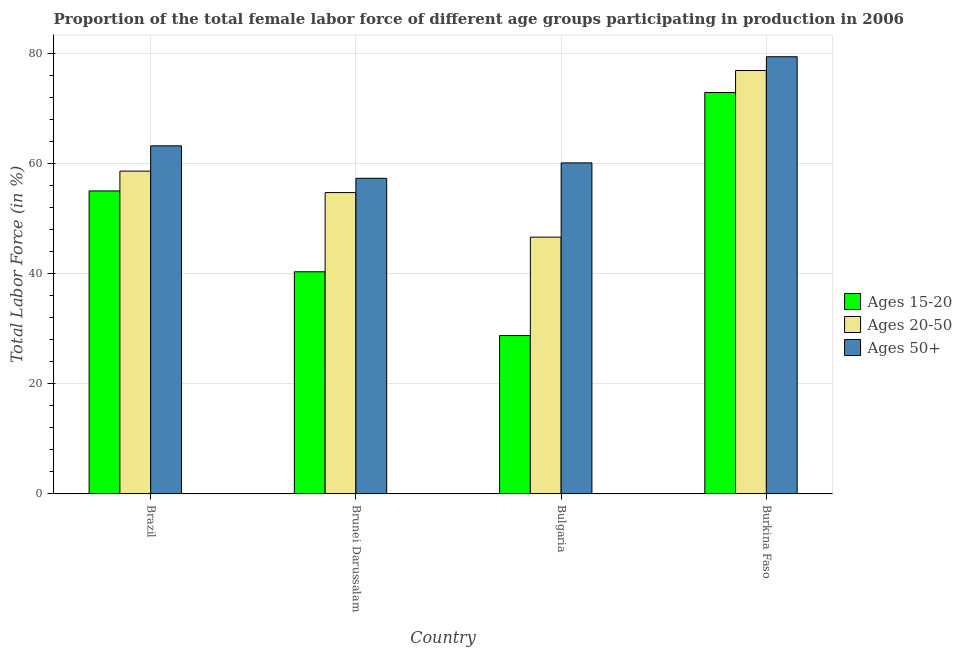How many groups of bars are there?
Your response must be concise. 4. Are the number of bars per tick equal to the number of legend labels?
Provide a short and direct response. Yes. How many bars are there on the 3rd tick from the left?
Offer a terse response. 3. How many bars are there on the 2nd tick from the right?
Give a very brief answer. 3. What is the label of the 3rd group of bars from the left?
Your answer should be compact. Bulgaria. In how many cases, is the number of bars for a given country not equal to the number of legend labels?
Your answer should be compact. 0. Across all countries, what is the maximum percentage of female labor force above age 50?
Provide a short and direct response. 79.5. Across all countries, what is the minimum percentage of female labor force above age 50?
Make the answer very short. 57.4. In which country was the percentage of female labor force above age 50 maximum?
Ensure brevity in your answer.  Burkina Faso. In which country was the percentage of female labor force within the age group 15-20 minimum?
Provide a short and direct response. Bulgaria. What is the total percentage of female labor force within the age group 20-50 in the graph?
Give a very brief answer. 237.2. What is the difference between the percentage of female labor force within the age group 20-50 in Brazil and that in Brunei Darussalam?
Make the answer very short. 3.9. What is the difference between the percentage of female labor force within the age group 20-50 in Brunei Darussalam and the percentage of female labor force within the age group 15-20 in Bulgaria?
Give a very brief answer. 26. What is the average percentage of female labor force above age 50 per country?
Ensure brevity in your answer.  65.1. What is the difference between the percentage of female labor force within the age group 20-50 and percentage of female labor force within the age group 15-20 in Bulgaria?
Ensure brevity in your answer.  17.9. In how many countries, is the percentage of female labor force within the age group 20-50 greater than 60 %?
Ensure brevity in your answer.  1. What is the ratio of the percentage of female labor force within the age group 15-20 in Bulgaria to that in Burkina Faso?
Your answer should be compact. 0.39. Is the difference between the percentage of female labor force within the age group 15-20 in Brazil and Burkina Faso greater than the difference between the percentage of female labor force within the age group 20-50 in Brazil and Burkina Faso?
Provide a succinct answer. Yes. What is the difference between the highest and the second highest percentage of female labor force within the age group 15-20?
Make the answer very short. 17.9. What is the difference between the highest and the lowest percentage of female labor force above age 50?
Ensure brevity in your answer.  22.1. What does the 2nd bar from the left in Brazil represents?
Offer a terse response. Ages 20-50. What does the 1st bar from the right in Bulgaria represents?
Provide a succinct answer. Ages 50+. Are all the bars in the graph horizontal?
Provide a short and direct response. No. What is the difference between two consecutive major ticks on the Y-axis?
Offer a terse response. 20. Are the values on the major ticks of Y-axis written in scientific E-notation?
Ensure brevity in your answer.  No. Does the graph contain any zero values?
Ensure brevity in your answer.  No. How many legend labels are there?
Your answer should be very brief. 3. How are the legend labels stacked?
Offer a very short reply. Vertical. What is the title of the graph?
Make the answer very short. Proportion of the total female labor force of different age groups participating in production in 2006. Does "Taxes" appear as one of the legend labels in the graph?
Ensure brevity in your answer.  No. What is the label or title of the X-axis?
Ensure brevity in your answer.  Country. What is the Total Labor Force (in %) of Ages 15-20 in Brazil?
Your answer should be very brief. 55.1. What is the Total Labor Force (in %) in Ages 20-50 in Brazil?
Keep it short and to the point. 58.7. What is the Total Labor Force (in %) of Ages 50+ in Brazil?
Ensure brevity in your answer.  63.3. What is the Total Labor Force (in %) of Ages 15-20 in Brunei Darussalam?
Make the answer very short. 40.4. What is the Total Labor Force (in %) of Ages 20-50 in Brunei Darussalam?
Make the answer very short. 54.8. What is the Total Labor Force (in %) of Ages 50+ in Brunei Darussalam?
Your answer should be very brief. 57.4. What is the Total Labor Force (in %) of Ages 15-20 in Bulgaria?
Keep it short and to the point. 28.8. What is the Total Labor Force (in %) of Ages 20-50 in Bulgaria?
Your response must be concise. 46.7. What is the Total Labor Force (in %) in Ages 50+ in Bulgaria?
Ensure brevity in your answer.  60.2. What is the Total Labor Force (in %) in Ages 15-20 in Burkina Faso?
Keep it short and to the point. 73. What is the Total Labor Force (in %) in Ages 20-50 in Burkina Faso?
Make the answer very short. 77. What is the Total Labor Force (in %) in Ages 50+ in Burkina Faso?
Your response must be concise. 79.5. Across all countries, what is the maximum Total Labor Force (in %) in Ages 50+?
Your answer should be compact. 79.5. Across all countries, what is the minimum Total Labor Force (in %) in Ages 15-20?
Offer a very short reply. 28.8. Across all countries, what is the minimum Total Labor Force (in %) of Ages 20-50?
Provide a short and direct response. 46.7. Across all countries, what is the minimum Total Labor Force (in %) in Ages 50+?
Give a very brief answer. 57.4. What is the total Total Labor Force (in %) of Ages 15-20 in the graph?
Your response must be concise. 197.3. What is the total Total Labor Force (in %) of Ages 20-50 in the graph?
Give a very brief answer. 237.2. What is the total Total Labor Force (in %) in Ages 50+ in the graph?
Keep it short and to the point. 260.4. What is the difference between the Total Labor Force (in %) in Ages 15-20 in Brazil and that in Brunei Darussalam?
Your response must be concise. 14.7. What is the difference between the Total Labor Force (in %) of Ages 15-20 in Brazil and that in Bulgaria?
Offer a very short reply. 26.3. What is the difference between the Total Labor Force (in %) of Ages 15-20 in Brazil and that in Burkina Faso?
Offer a terse response. -17.9. What is the difference between the Total Labor Force (in %) of Ages 20-50 in Brazil and that in Burkina Faso?
Provide a short and direct response. -18.3. What is the difference between the Total Labor Force (in %) in Ages 50+ in Brazil and that in Burkina Faso?
Make the answer very short. -16.2. What is the difference between the Total Labor Force (in %) of Ages 15-20 in Brunei Darussalam and that in Bulgaria?
Ensure brevity in your answer.  11.6. What is the difference between the Total Labor Force (in %) of Ages 50+ in Brunei Darussalam and that in Bulgaria?
Offer a very short reply. -2.8. What is the difference between the Total Labor Force (in %) of Ages 15-20 in Brunei Darussalam and that in Burkina Faso?
Give a very brief answer. -32.6. What is the difference between the Total Labor Force (in %) of Ages 20-50 in Brunei Darussalam and that in Burkina Faso?
Your response must be concise. -22.2. What is the difference between the Total Labor Force (in %) of Ages 50+ in Brunei Darussalam and that in Burkina Faso?
Your answer should be compact. -22.1. What is the difference between the Total Labor Force (in %) of Ages 15-20 in Bulgaria and that in Burkina Faso?
Provide a short and direct response. -44.2. What is the difference between the Total Labor Force (in %) in Ages 20-50 in Bulgaria and that in Burkina Faso?
Give a very brief answer. -30.3. What is the difference between the Total Labor Force (in %) of Ages 50+ in Bulgaria and that in Burkina Faso?
Your answer should be very brief. -19.3. What is the difference between the Total Labor Force (in %) in Ages 15-20 in Brazil and the Total Labor Force (in %) in Ages 20-50 in Brunei Darussalam?
Your response must be concise. 0.3. What is the difference between the Total Labor Force (in %) of Ages 15-20 in Brazil and the Total Labor Force (in %) of Ages 20-50 in Burkina Faso?
Your response must be concise. -21.9. What is the difference between the Total Labor Force (in %) in Ages 15-20 in Brazil and the Total Labor Force (in %) in Ages 50+ in Burkina Faso?
Offer a very short reply. -24.4. What is the difference between the Total Labor Force (in %) of Ages 20-50 in Brazil and the Total Labor Force (in %) of Ages 50+ in Burkina Faso?
Provide a short and direct response. -20.8. What is the difference between the Total Labor Force (in %) in Ages 15-20 in Brunei Darussalam and the Total Labor Force (in %) in Ages 50+ in Bulgaria?
Ensure brevity in your answer.  -19.8. What is the difference between the Total Labor Force (in %) in Ages 20-50 in Brunei Darussalam and the Total Labor Force (in %) in Ages 50+ in Bulgaria?
Offer a very short reply. -5.4. What is the difference between the Total Labor Force (in %) in Ages 15-20 in Brunei Darussalam and the Total Labor Force (in %) in Ages 20-50 in Burkina Faso?
Offer a very short reply. -36.6. What is the difference between the Total Labor Force (in %) in Ages 15-20 in Brunei Darussalam and the Total Labor Force (in %) in Ages 50+ in Burkina Faso?
Give a very brief answer. -39.1. What is the difference between the Total Labor Force (in %) in Ages 20-50 in Brunei Darussalam and the Total Labor Force (in %) in Ages 50+ in Burkina Faso?
Your answer should be compact. -24.7. What is the difference between the Total Labor Force (in %) in Ages 15-20 in Bulgaria and the Total Labor Force (in %) in Ages 20-50 in Burkina Faso?
Your response must be concise. -48.2. What is the difference between the Total Labor Force (in %) in Ages 15-20 in Bulgaria and the Total Labor Force (in %) in Ages 50+ in Burkina Faso?
Your response must be concise. -50.7. What is the difference between the Total Labor Force (in %) in Ages 20-50 in Bulgaria and the Total Labor Force (in %) in Ages 50+ in Burkina Faso?
Your answer should be very brief. -32.8. What is the average Total Labor Force (in %) in Ages 15-20 per country?
Keep it short and to the point. 49.33. What is the average Total Labor Force (in %) of Ages 20-50 per country?
Your answer should be very brief. 59.3. What is the average Total Labor Force (in %) in Ages 50+ per country?
Ensure brevity in your answer.  65.1. What is the difference between the Total Labor Force (in %) in Ages 15-20 and Total Labor Force (in %) in Ages 20-50 in Brazil?
Your answer should be very brief. -3.6. What is the difference between the Total Labor Force (in %) in Ages 15-20 and Total Labor Force (in %) in Ages 20-50 in Brunei Darussalam?
Offer a terse response. -14.4. What is the difference between the Total Labor Force (in %) of Ages 20-50 and Total Labor Force (in %) of Ages 50+ in Brunei Darussalam?
Make the answer very short. -2.6. What is the difference between the Total Labor Force (in %) of Ages 15-20 and Total Labor Force (in %) of Ages 20-50 in Bulgaria?
Provide a succinct answer. -17.9. What is the difference between the Total Labor Force (in %) of Ages 15-20 and Total Labor Force (in %) of Ages 50+ in Bulgaria?
Ensure brevity in your answer.  -31.4. What is the difference between the Total Labor Force (in %) of Ages 20-50 and Total Labor Force (in %) of Ages 50+ in Bulgaria?
Provide a short and direct response. -13.5. What is the difference between the Total Labor Force (in %) in Ages 15-20 and Total Labor Force (in %) in Ages 20-50 in Burkina Faso?
Your answer should be compact. -4. What is the difference between the Total Labor Force (in %) in Ages 15-20 and Total Labor Force (in %) in Ages 50+ in Burkina Faso?
Your response must be concise. -6.5. What is the difference between the Total Labor Force (in %) in Ages 20-50 and Total Labor Force (in %) in Ages 50+ in Burkina Faso?
Keep it short and to the point. -2.5. What is the ratio of the Total Labor Force (in %) in Ages 15-20 in Brazil to that in Brunei Darussalam?
Your answer should be very brief. 1.36. What is the ratio of the Total Labor Force (in %) of Ages 20-50 in Brazil to that in Brunei Darussalam?
Make the answer very short. 1.07. What is the ratio of the Total Labor Force (in %) in Ages 50+ in Brazil to that in Brunei Darussalam?
Provide a short and direct response. 1.1. What is the ratio of the Total Labor Force (in %) of Ages 15-20 in Brazil to that in Bulgaria?
Offer a very short reply. 1.91. What is the ratio of the Total Labor Force (in %) in Ages 20-50 in Brazil to that in Bulgaria?
Offer a terse response. 1.26. What is the ratio of the Total Labor Force (in %) of Ages 50+ in Brazil to that in Bulgaria?
Your answer should be very brief. 1.05. What is the ratio of the Total Labor Force (in %) of Ages 15-20 in Brazil to that in Burkina Faso?
Keep it short and to the point. 0.75. What is the ratio of the Total Labor Force (in %) in Ages 20-50 in Brazil to that in Burkina Faso?
Your answer should be compact. 0.76. What is the ratio of the Total Labor Force (in %) in Ages 50+ in Brazil to that in Burkina Faso?
Your answer should be very brief. 0.8. What is the ratio of the Total Labor Force (in %) in Ages 15-20 in Brunei Darussalam to that in Bulgaria?
Give a very brief answer. 1.4. What is the ratio of the Total Labor Force (in %) in Ages 20-50 in Brunei Darussalam to that in Bulgaria?
Offer a very short reply. 1.17. What is the ratio of the Total Labor Force (in %) of Ages 50+ in Brunei Darussalam to that in Bulgaria?
Offer a terse response. 0.95. What is the ratio of the Total Labor Force (in %) of Ages 15-20 in Brunei Darussalam to that in Burkina Faso?
Offer a very short reply. 0.55. What is the ratio of the Total Labor Force (in %) of Ages 20-50 in Brunei Darussalam to that in Burkina Faso?
Your answer should be compact. 0.71. What is the ratio of the Total Labor Force (in %) in Ages 50+ in Brunei Darussalam to that in Burkina Faso?
Your answer should be compact. 0.72. What is the ratio of the Total Labor Force (in %) in Ages 15-20 in Bulgaria to that in Burkina Faso?
Offer a terse response. 0.39. What is the ratio of the Total Labor Force (in %) of Ages 20-50 in Bulgaria to that in Burkina Faso?
Give a very brief answer. 0.61. What is the ratio of the Total Labor Force (in %) in Ages 50+ in Bulgaria to that in Burkina Faso?
Your answer should be compact. 0.76. What is the difference between the highest and the second highest Total Labor Force (in %) in Ages 20-50?
Offer a terse response. 18.3. What is the difference between the highest and the second highest Total Labor Force (in %) of Ages 50+?
Give a very brief answer. 16.2. What is the difference between the highest and the lowest Total Labor Force (in %) in Ages 15-20?
Ensure brevity in your answer.  44.2. What is the difference between the highest and the lowest Total Labor Force (in %) in Ages 20-50?
Ensure brevity in your answer.  30.3. What is the difference between the highest and the lowest Total Labor Force (in %) in Ages 50+?
Provide a succinct answer. 22.1. 